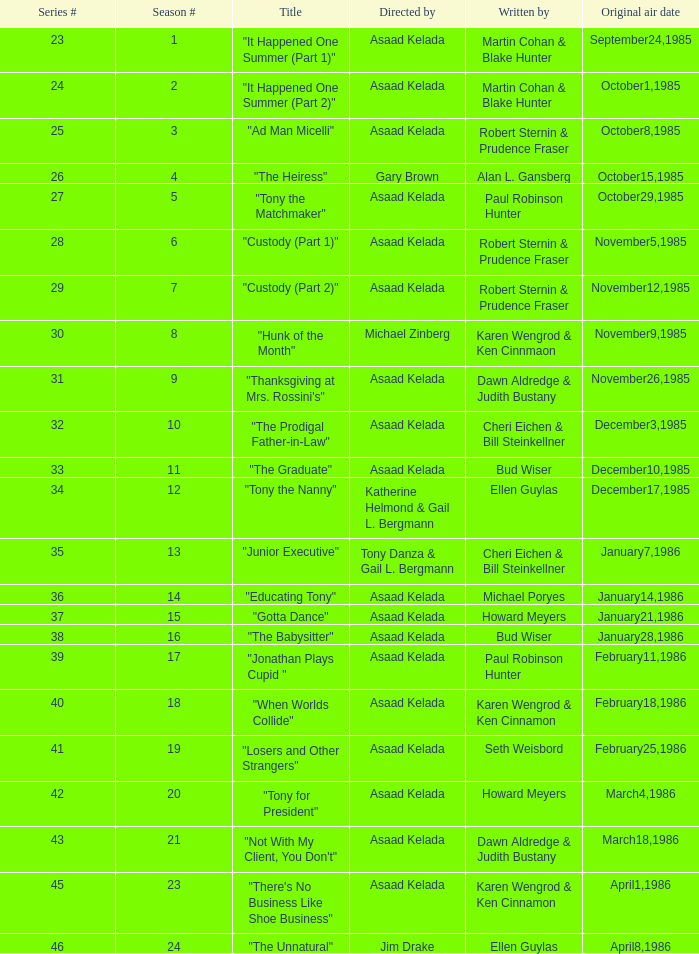Can you name the writers of the 25th episode in the series? Robert Sternin & Prudence Fraser. 